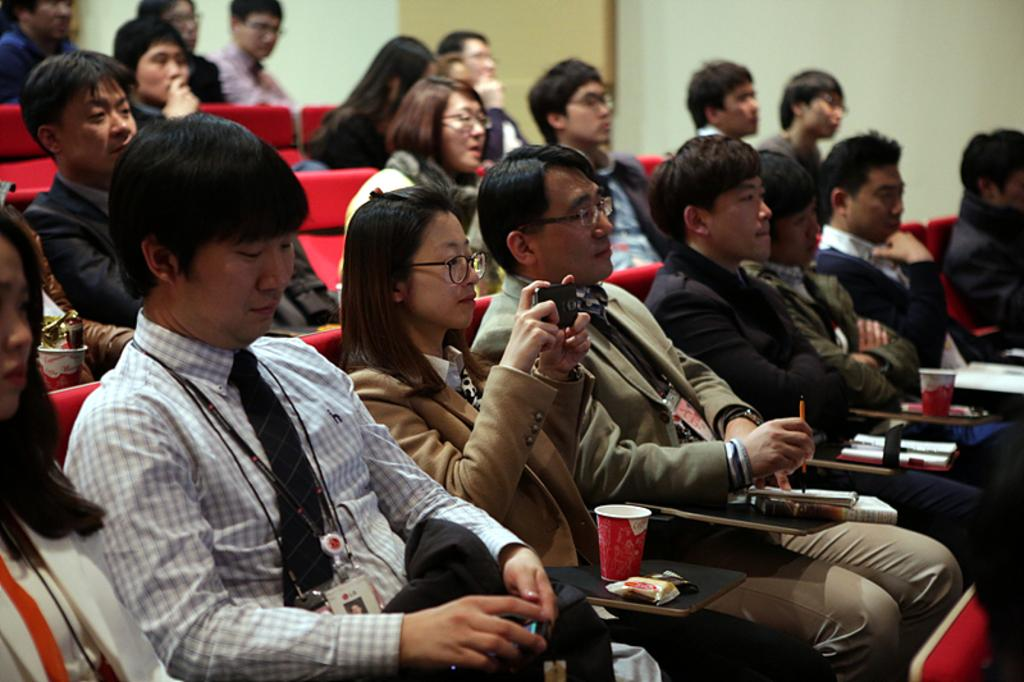How many persons are in the image? There are persons in the image. What can be observed about the dresses worn by the persons? The persons are wearing different color dresses. What are the chairs on which the persons are sitting? The chairs are red color chairs. Where are the chairs placed? The chairs are arranged on a floor. What is visible in the background of the image? There is a white wall in the background. What time is displayed on the clock in the image? There is no clock present in the image. What type of dress is the person wearing in the image? The provided facts only mention that the persons are wearing different color dresses, but they do not specify the type of dress. 